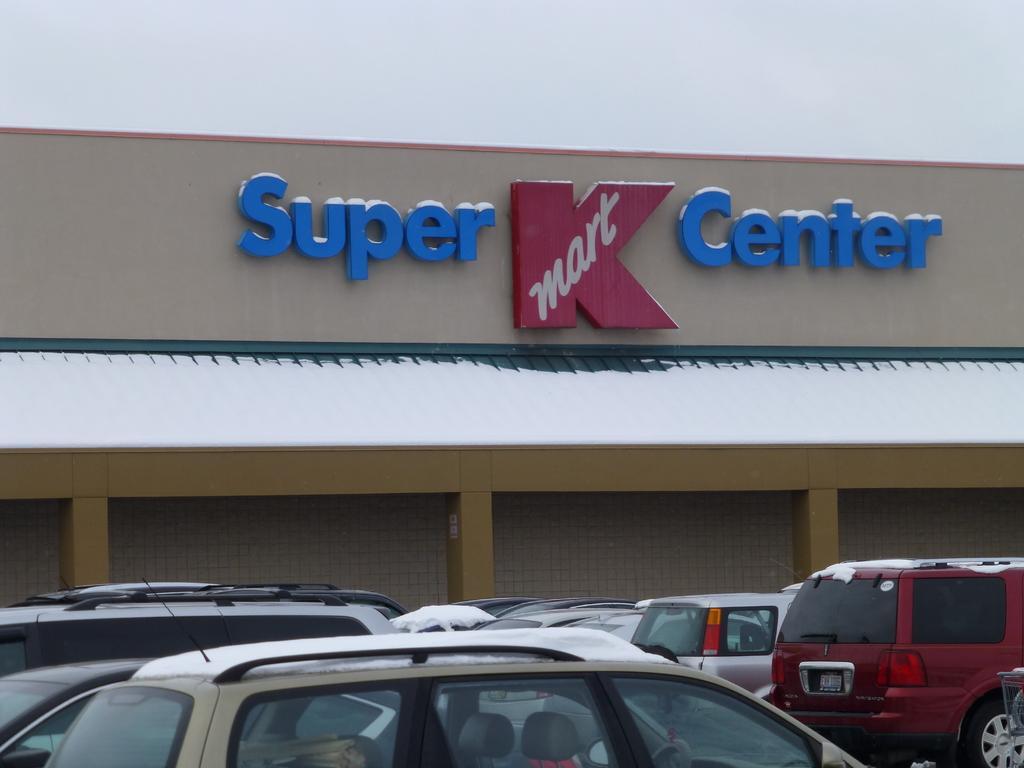In one or two sentences, can you explain what this image depicts? In this image we can see cars, pillars, walls, and a letters board. In the background there is sky. 